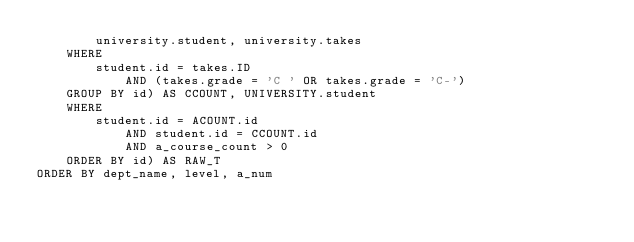Convert code to text. <code><loc_0><loc_0><loc_500><loc_500><_SQL_>        university.student, university.takes
    WHERE
        student.id = takes.ID
            AND (takes.grade = 'C ' OR takes.grade = 'C-')
    GROUP BY id) AS CCOUNT, UNIVERSITY.student
    WHERE
        student.id = ACOUNT.id
            AND student.id = CCOUNT.id
            AND a_course_count > 0
    ORDER BY id) AS RAW_T
ORDER BY dept_name, level, a_num</code> 